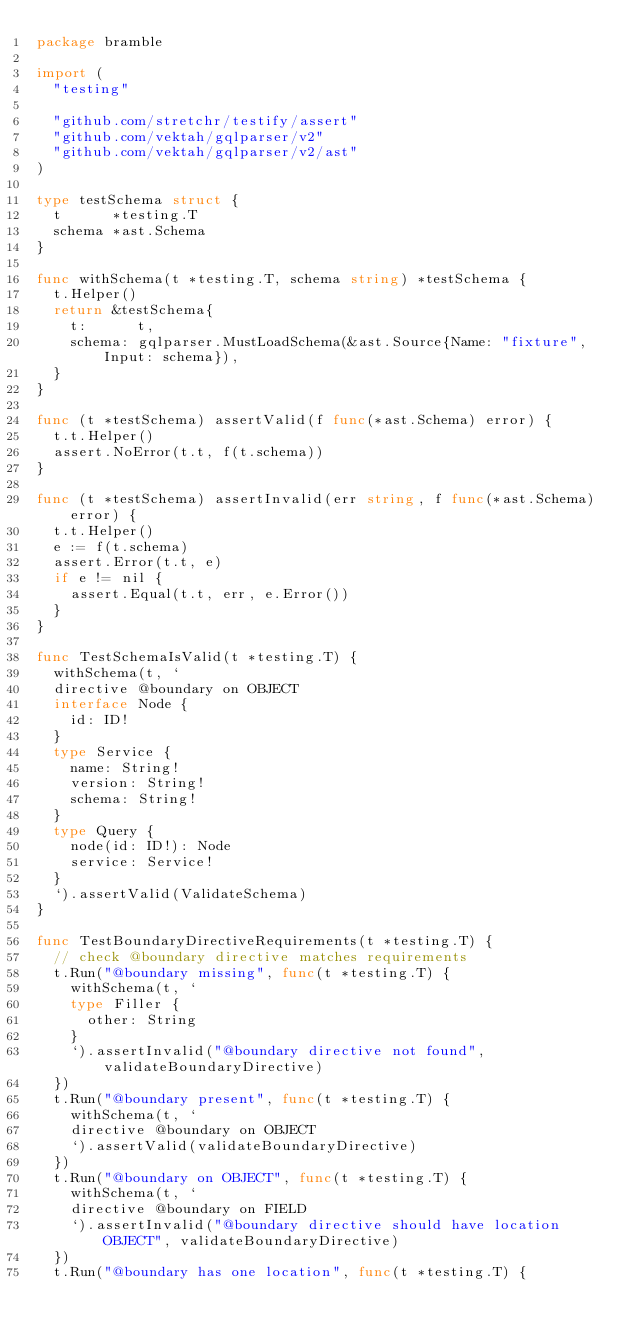<code> <loc_0><loc_0><loc_500><loc_500><_Go_>package bramble

import (
	"testing"

	"github.com/stretchr/testify/assert"
	"github.com/vektah/gqlparser/v2"
	"github.com/vektah/gqlparser/v2/ast"
)

type testSchema struct {
	t      *testing.T
	schema *ast.Schema
}

func withSchema(t *testing.T, schema string) *testSchema {
	t.Helper()
	return &testSchema{
		t:      t,
		schema: gqlparser.MustLoadSchema(&ast.Source{Name: "fixture", Input: schema}),
	}
}

func (t *testSchema) assertValid(f func(*ast.Schema) error) {
	t.t.Helper()
	assert.NoError(t.t, f(t.schema))
}

func (t *testSchema) assertInvalid(err string, f func(*ast.Schema) error) {
	t.t.Helper()
	e := f(t.schema)
	assert.Error(t.t, e)
	if e != nil {
		assert.Equal(t.t, err, e.Error())
	}
}

func TestSchemaIsValid(t *testing.T) {
	withSchema(t, `
	directive @boundary on OBJECT
	interface Node {
		id: ID!
	}
	type Service {
		name: String!
		version: String!
		schema: String!
	}
	type Query {
		node(id: ID!): Node
		service: Service!
	}
	`).assertValid(ValidateSchema)
}

func TestBoundaryDirectiveRequirements(t *testing.T) {
	// check @boundary directive matches requirements
	t.Run("@boundary missing", func(t *testing.T) {
		withSchema(t, `
		type Filler {
			other: String
		}
		`).assertInvalid("@boundary directive not found", validateBoundaryDirective)
	})
	t.Run("@boundary present", func(t *testing.T) {
		withSchema(t, `
		directive @boundary on OBJECT
		`).assertValid(validateBoundaryDirective)
	})
	t.Run("@boundary on OBJECT", func(t *testing.T) {
		withSchema(t, `
		directive @boundary on FIELD
		`).assertInvalid("@boundary directive should have location OBJECT", validateBoundaryDirective)
	})
	t.Run("@boundary has one location", func(t *testing.T) {</code> 